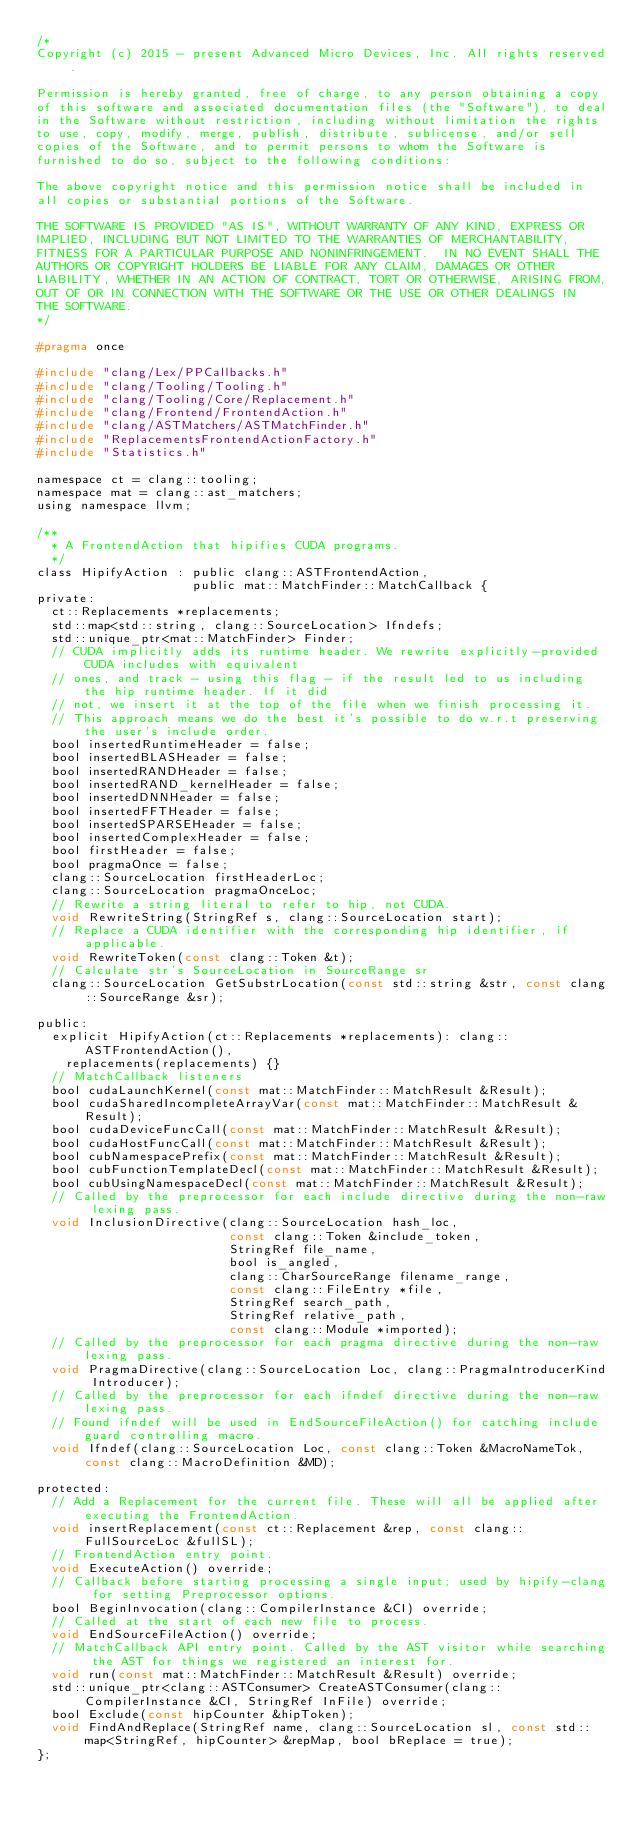<code> <loc_0><loc_0><loc_500><loc_500><_C_>/*
Copyright (c) 2015 - present Advanced Micro Devices, Inc. All rights reserved.

Permission is hereby granted, free of charge, to any person obtaining a copy
of this software and associated documentation files (the "Software"), to deal
in the Software without restriction, including without limitation the rights
to use, copy, modify, merge, publish, distribute, sublicense, and/or sell
copies of the Software, and to permit persons to whom the Software is
furnished to do so, subject to the following conditions:

The above copyright notice and this permission notice shall be included in
all copies or substantial portions of the Software.

THE SOFTWARE IS PROVIDED "AS IS", WITHOUT WARRANTY OF ANY KIND, EXPRESS OR
IMPLIED, INCLUDING BUT NOT LIMITED TO THE WARRANTIES OF MERCHANTABILITY,
FITNESS FOR A PARTICULAR PURPOSE AND NONINFRINGEMENT.  IN NO EVENT SHALL THE
AUTHORS OR COPYRIGHT HOLDERS BE LIABLE FOR ANY CLAIM, DAMAGES OR OTHER
LIABILITY, WHETHER IN AN ACTION OF CONTRACT, TORT OR OTHERWISE, ARISING FROM,
OUT OF OR IN CONNECTION WITH THE SOFTWARE OR THE USE OR OTHER DEALINGS IN
THE SOFTWARE.
*/

#pragma once

#include "clang/Lex/PPCallbacks.h"
#include "clang/Tooling/Tooling.h"
#include "clang/Tooling/Core/Replacement.h"
#include "clang/Frontend/FrontendAction.h"
#include "clang/ASTMatchers/ASTMatchFinder.h"
#include "ReplacementsFrontendActionFactory.h"
#include "Statistics.h"

namespace ct = clang::tooling;
namespace mat = clang::ast_matchers;
using namespace llvm;

/**
  * A FrontendAction that hipifies CUDA programs.
  */
class HipifyAction : public clang::ASTFrontendAction,
                     public mat::MatchFinder::MatchCallback {
private:
  ct::Replacements *replacements;
  std::map<std::string, clang::SourceLocation> Ifndefs;
  std::unique_ptr<mat::MatchFinder> Finder;
  // CUDA implicitly adds its runtime header. We rewrite explicitly-provided CUDA includes with equivalent
  // ones, and track - using this flag - if the result led to us including the hip runtime header. If it did
  // not, we insert it at the top of the file when we finish processing it.
  // This approach means we do the best it's possible to do w.r.t preserving the user's include order.
  bool insertedRuntimeHeader = false;
  bool insertedBLASHeader = false;
  bool insertedRANDHeader = false;
  bool insertedRAND_kernelHeader = false;
  bool insertedDNNHeader = false;
  bool insertedFFTHeader = false;
  bool insertedSPARSEHeader = false;
  bool insertedComplexHeader = false;
  bool firstHeader = false;
  bool pragmaOnce = false;
  clang::SourceLocation firstHeaderLoc;
  clang::SourceLocation pragmaOnceLoc;
  // Rewrite a string literal to refer to hip, not CUDA.
  void RewriteString(StringRef s, clang::SourceLocation start);
  // Replace a CUDA identifier with the corresponding hip identifier, if applicable.
  void RewriteToken(const clang::Token &t);
  // Calculate str's SourceLocation in SourceRange sr
  clang::SourceLocation GetSubstrLocation(const std::string &str, const clang::SourceRange &sr);

public:
  explicit HipifyAction(ct::Replacements *replacements): clang::ASTFrontendAction(),
    replacements(replacements) {}
  // MatchCallback listeners
  bool cudaLaunchKernel(const mat::MatchFinder::MatchResult &Result);
  bool cudaSharedIncompleteArrayVar(const mat::MatchFinder::MatchResult &Result);
  bool cudaDeviceFuncCall(const mat::MatchFinder::MatchResult &Result);
  bool cudaHostFuncCall(const mat::MatchFinder::MatchResult &Result);
  bool cubNamespacePrefix(const mat::MatchFinder::MatchResult &Result);
  bool cubFunctionTemplateDecl(const mat::MatchFinder::MatchResult &Result);
  bool cubUsingNamespaceDecl(const mat::MatchFinder::MatchResult &Result);
  // Called by the preprocessor for each include directive during the non-raw lexing pass.
  void InclusionDirective(clang::SourceLocation hash_loc,
                          const clang::Token &include_token,
                          StringRef file_name,
                          bool is_angled,
                          clang::CharSourceRange filename_range,
                          const clang::FileEntry *file,
                          StringRef search_path,
                          StringRef relative_path,
                          const clang::Module *imported);
  // Called by the preprocessor for each pragma directive during the non-raw lexing pass.
  void PragmaDirective(clang::SourceLocation Loc, clang::PragmaIntroducerKind Introducer);
  // Called by the preprocessor for each ifndef directive during the non-raw lexing pass.
  // Found ifndef will be used in EndSourceFileAction() for catching include guard controlling macro.
  void Ifndef(clang::SourceLocation Loc, const clang::Token &MacroNameTok, const clang::MacroDefinition &MD);

protected:
  // Add a Replacement for the current file. These will all be applied after executing the FrontendAction.
  void insertReplacement(const ct::Replacement &rep, const clang::FullSourceLoc &fullSL);
  // FrontendAction entry point.
  void ExecuteAction() override;
  // Callback before starting processing a single input; used by hipify-clang for setting Preprocessor options.
  bool BeginInvocation(clang::CompilerInstance &CI) override;
  // Called at the start of each new file to process.
  void EndSourceFileAction() override;
  // MatchCallback API entry point. Called by the AST visitor while searching the AST for things we registered an interest for.
  void run(const mat::MatchFinder::MatchResult &Result) override;
  std::unique_ptr<clang::ASTConsumer> CreateASTConsumer(clang::CompilerInstance &CI, StringRef InFile) override;
  bool Exclude(const hipCounter &hipToken);
  void FindAndReplace(StringRef name, clang::SourceLocation sl, const std::map<StringRef, hipCounter> &repMap, bool bReplace = true);
};
</code> 